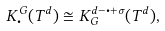<formula> <loc_0><loc_0><loc_500><loc_500>K _ { \bullet } ^ { G } ( T ^ { d } ) \cong K ^ { d - \bullet + \sigma } _ { G } ( T ^ { d } ) ,</formula> 